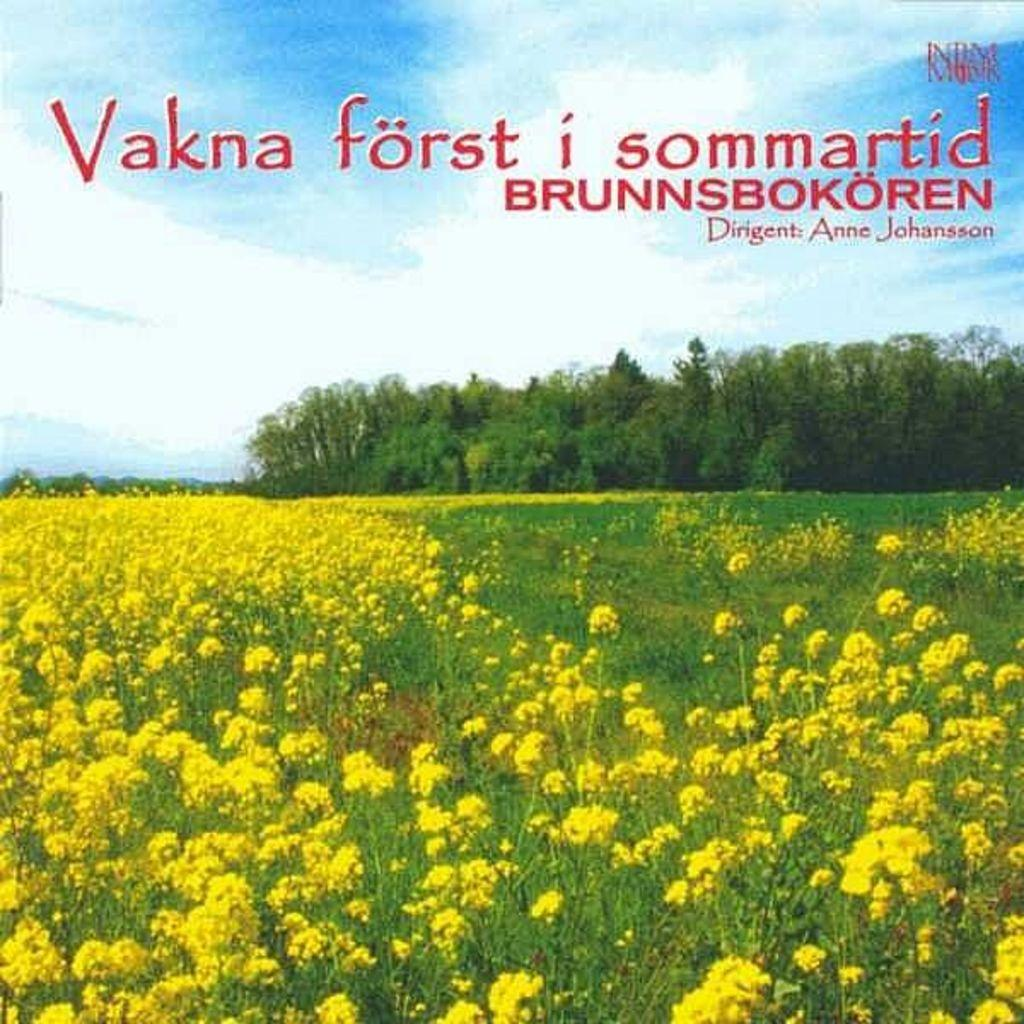What type of plants can be seen in the image? There are flower plants in the image. What color are the flowers? The flowers are yellow in color. What can be seen in the background of the image? There are trees in the background of the image. Are there any visible marks or patterns on the image? Yes, watermarks are present on the image. How many ducks are visible in the image? There are no ducks present in the image. What type of camera was used to capture the image? The information provided does not mention the camera used to capture the image. 